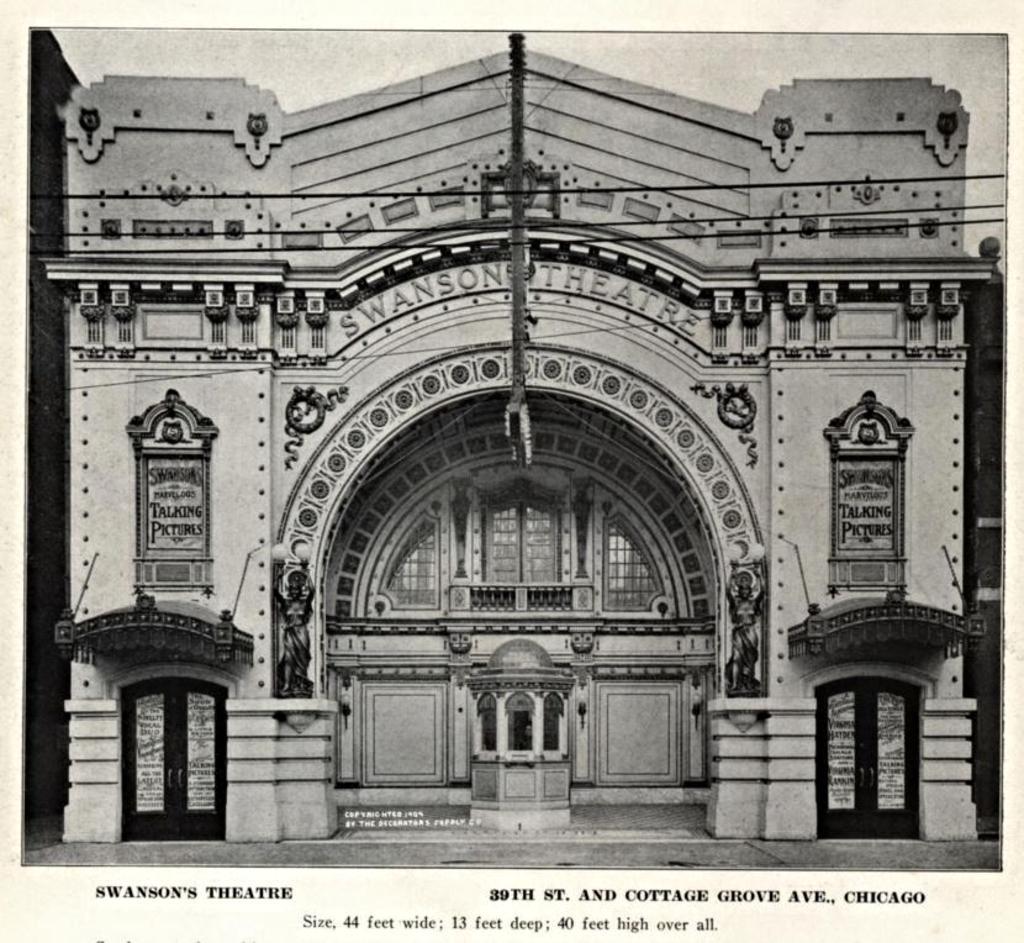Describe this image in one or two sentences. In this picture we can see a black and white photograph, here we can see a building, a glass window, a board and some wires, at the bottom there is some text. 